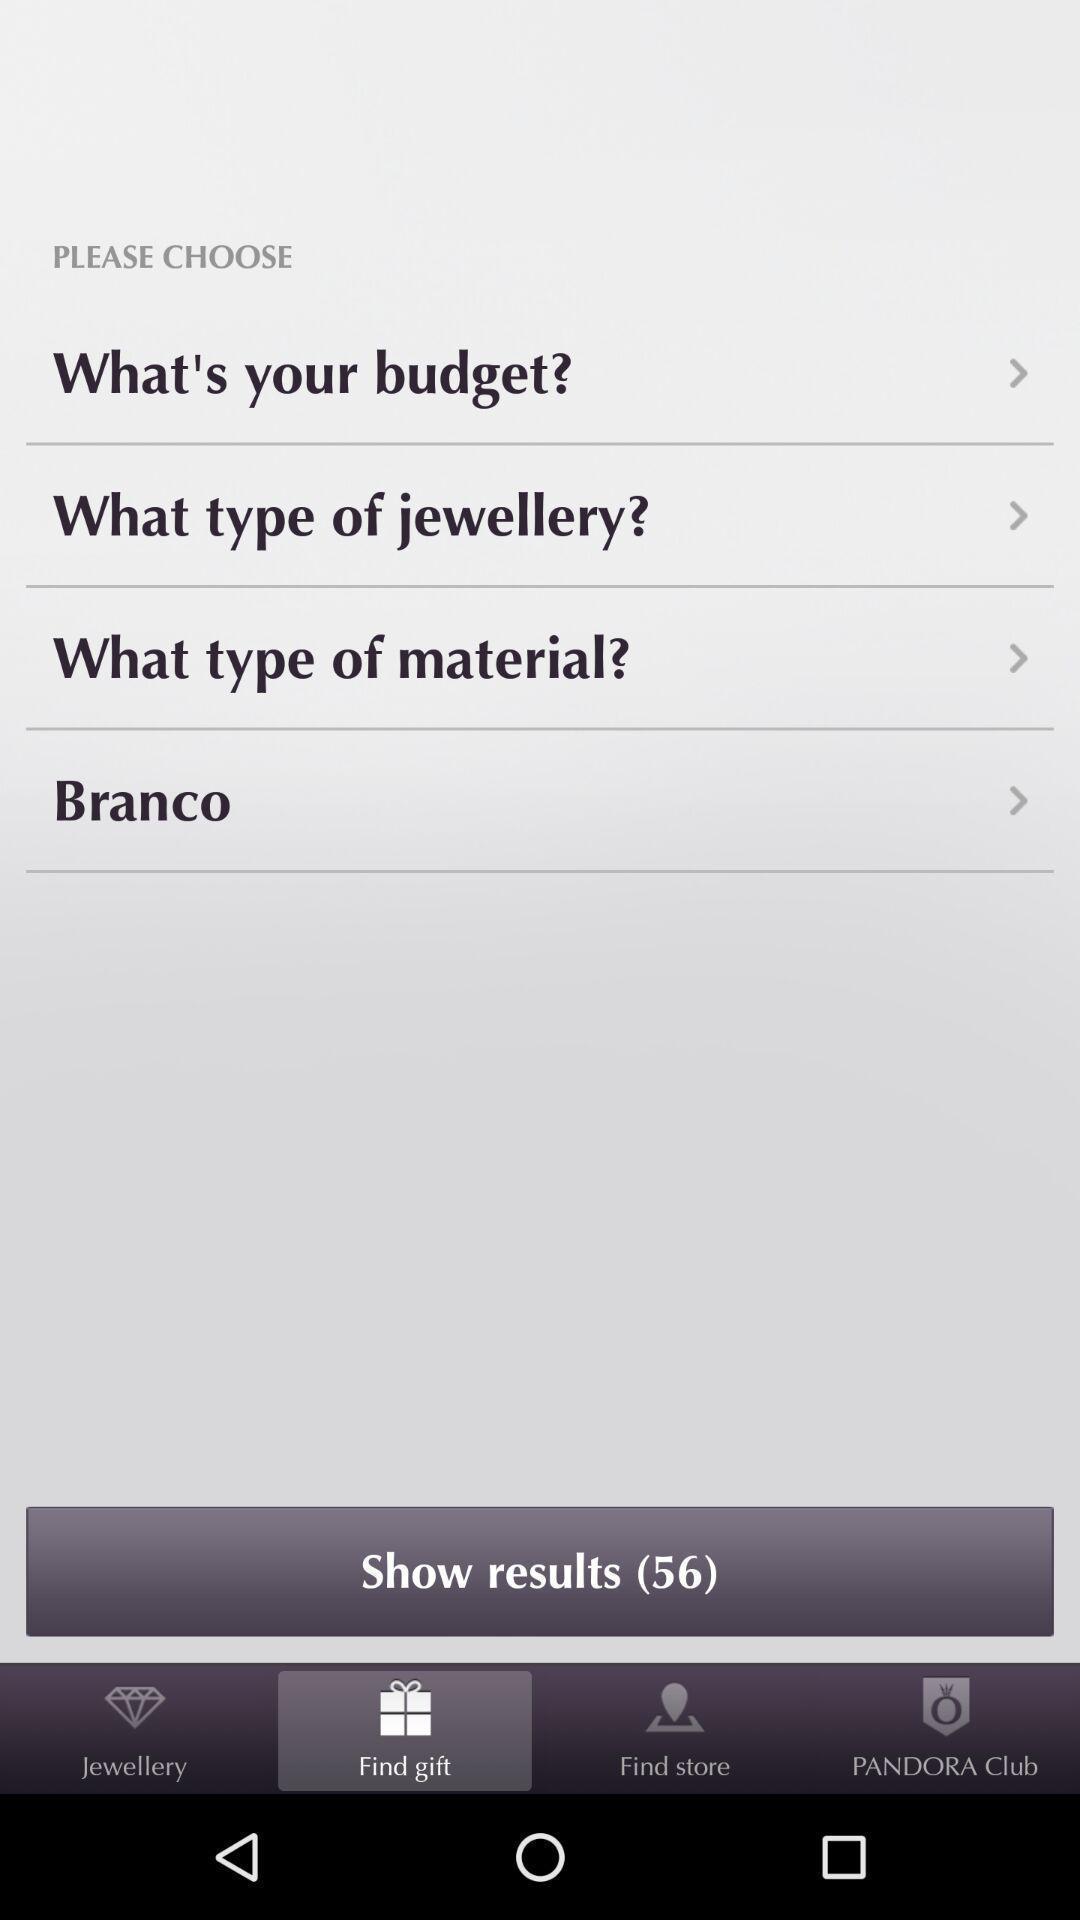What details can you identify in this image? Window displaying an shopping app. 